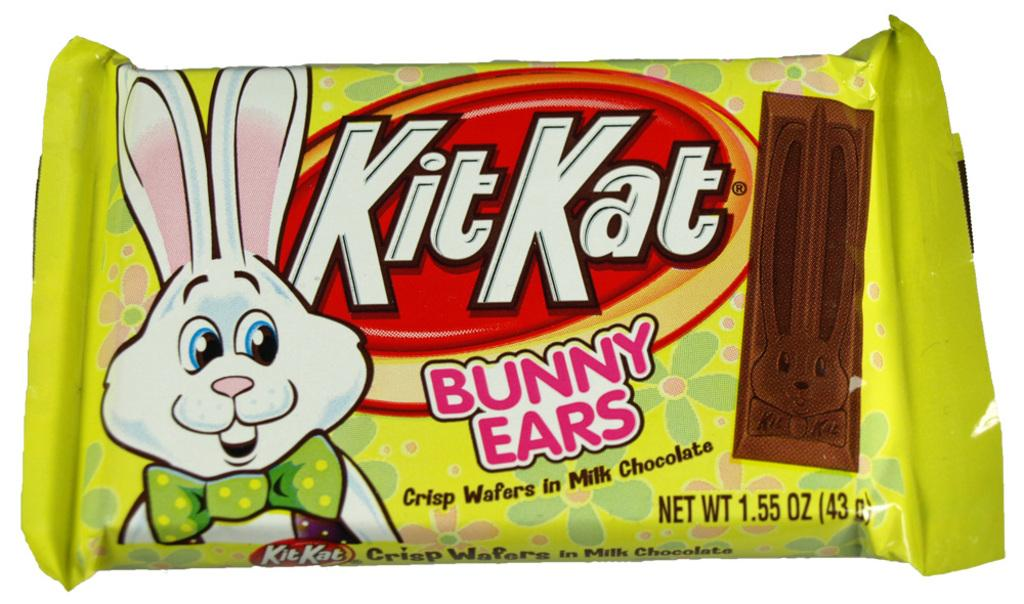What color is the packet in the image? The packet in the image is green. What is depicted on the packet? The packet has a cartoon bunny on it. What is inside the packet? The packet contains chocolate. What can be found on the packet besides the cartoon bunny? There is text written on the packet and a logo on it. How many mice are hiding behind the cartoon bunny on the packet? There are no mice present on the packet; it features a cartoon bunny and other text and design elements. 